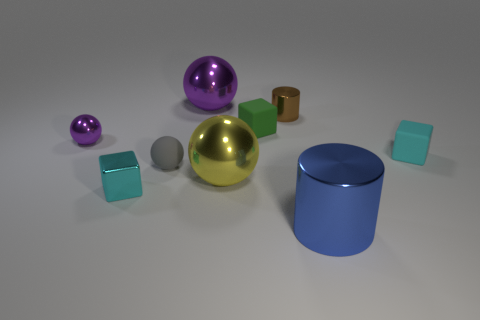Is there a cyan matte block that has the same size as the green matte block?
Offer a terse response. Yes. The shiny cylinder that is behind the small cyan rubber block is what color?
Provide a short and direct response. Brown. There is a blue shiny thing in front of the large yellow shiny thing; are there any brown cylinders that are in front of it?
Ensure brevity in your answer.  No. How many other objects are the same color as the big metal cylinder?
Your response must be concise. 0. There is a cyan object left of the small cylinder; is it the same size as the cylinder in front of the large yellow object?
Keep it short and to the point. No. There is a metallic cylinder in front of the tiny cyan cube that is on the left side of the green matte object; what size is it?
Ensure brevity in your answer.  Large. There is a big thing that is in front of the gray matte thing and behind the tiny cyan shiny cube; what material is it?
Provide a succinct answer. Metal. What color is the tiny metallic ball?
Provide a succinct answer. Purple. There is a cyan object right of the tiny green block; what shape is it?
Offer a very short reply. Cube. Is there a blue metallic cylinder that is behind the tiny cube in front of the object on the right side of the large blue cylinder?
Make the answer very short. No. 